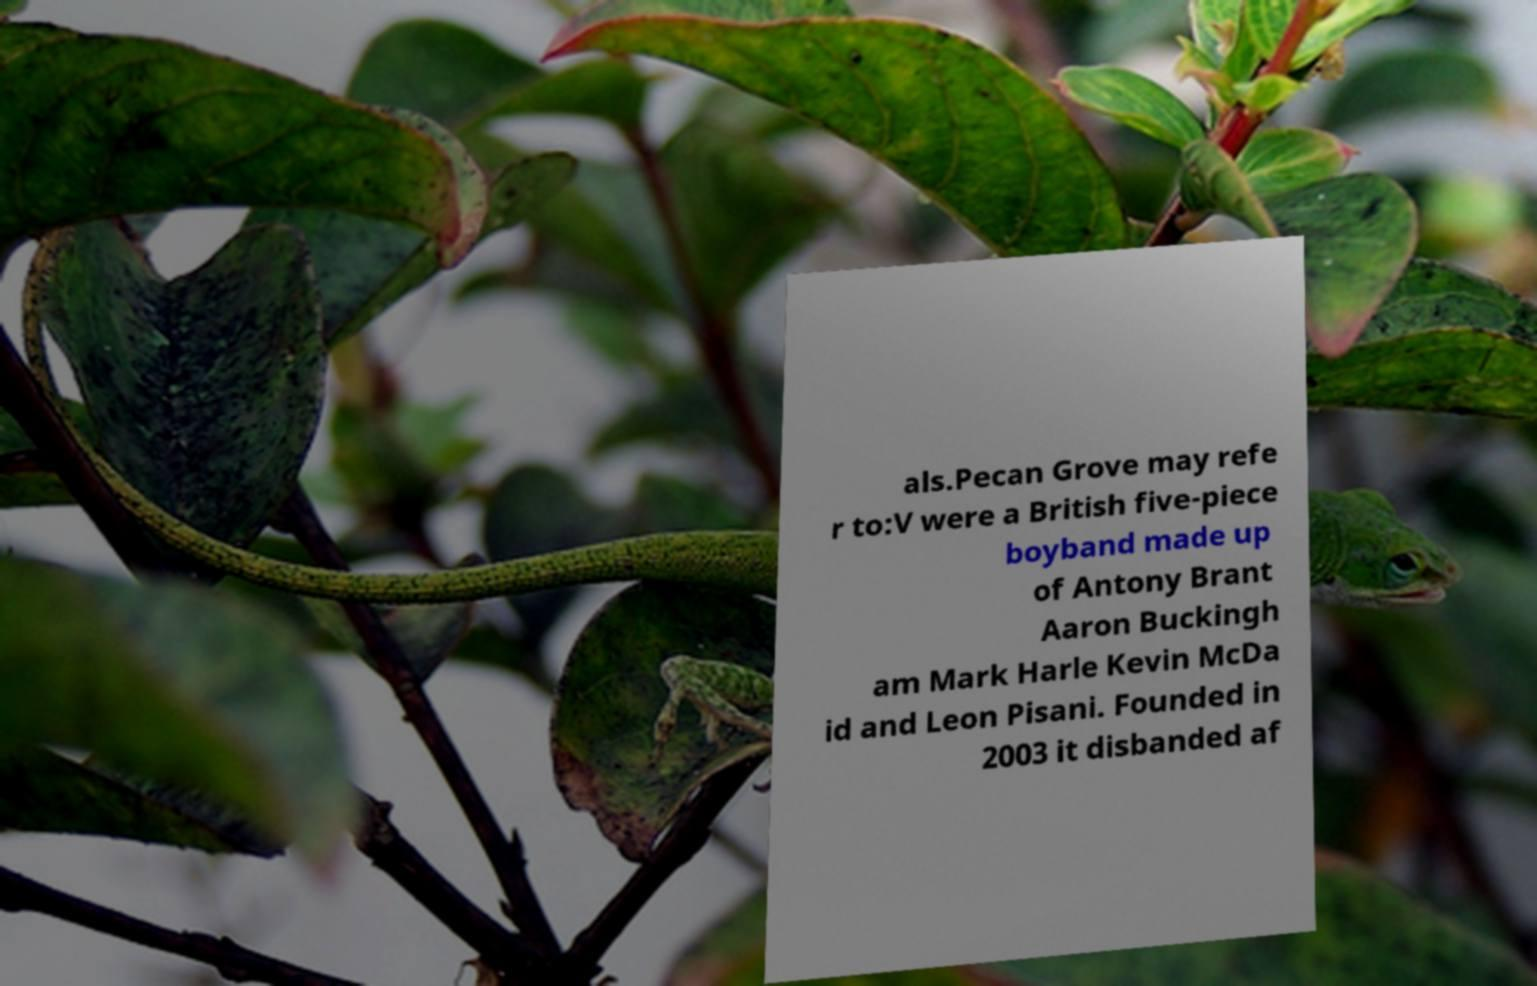Please identify and transcribe the text found in this image. als.Pecan Grove may refe r to:V were a British five-piece boyband made up of Antony Brant Aaron Buckingh am Mark Harle Kevin McDa id and Leon Pisani. Founded in 2003 it disbanded af 